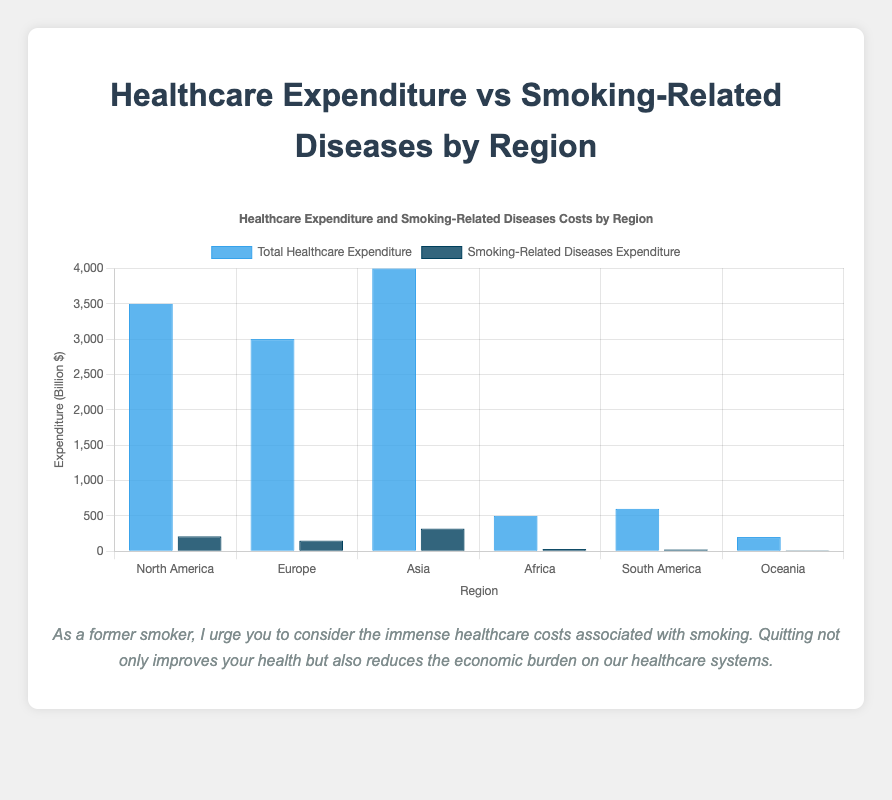What's the total healthcare expenditure for Europe and Oceania combined? Europe's total healthcare expenditure is 3000 billion $, and Oceania's is 200 billion $. Adding these together: 3000 + 200 = 3200 billion $.
Answer: 3200 billion $ Which region has the highest expenditure on smoking-related diseases? The region with the highest expenditure on smoking-related diseases is Asia, with 320 billion $.
Answer: Asia How much more is North America's total healthcare expenditure than Africa's? North America's total healthcare expenditure is 3500 billion $, and Africa's is 500 billion $. The difference is 3500 - 500 = 3000 billion $.
Answer: 3000 billion $ Which has a higher total expenditure on healthcare, South America or Africa? South America's total healthcare expenditure is 600 billion $, and Africa's is 500 billion $. Since 600 is greater than 500, South America has a higher expenditure.
Answer: South America What is the ratio of smoking-related diseases expenditure to total healthcare expenditure in Asia? Smoking-related diseases expenditure in Asia is 320 billion $, and total healthcare expenditure is 4000 billion $. The ratio is 320/4000, which simplifies to 0.08.
Answer: 0.08 Which region has the lowest total healthcare expenditure? The region with the lowest total healthcare expenditure is Oceania, with 200 billion $.
Answer: Oceania In terms of visual appearance, which dataset in North America has taller bars, total healthcare expenditure or smoking-related diseases expenditure? In the bar chart, North America's total healthcare expenditure bar is taller than the smoking-related diseases expenditure bar.
Answer: Total healthcare expenditure What is the combined smoking-related diseases expenditure for South America and Oceania? South America's smoking-related diseases expenditure is 25 billion $, and Oceania's is 12 billion $. Adding these together: 25 + 12 = 37 billion $.
Answer: 37 billion $ Is the healthcare expenditure on smoking-related diseases in Europe less than in North America? Europe’s expenditure on smoking-related diseases is 150 billion $, and North America's is 210 billion $. Since 150 is less than 210, Europe’s expenditure is less.
Answer: Yes 